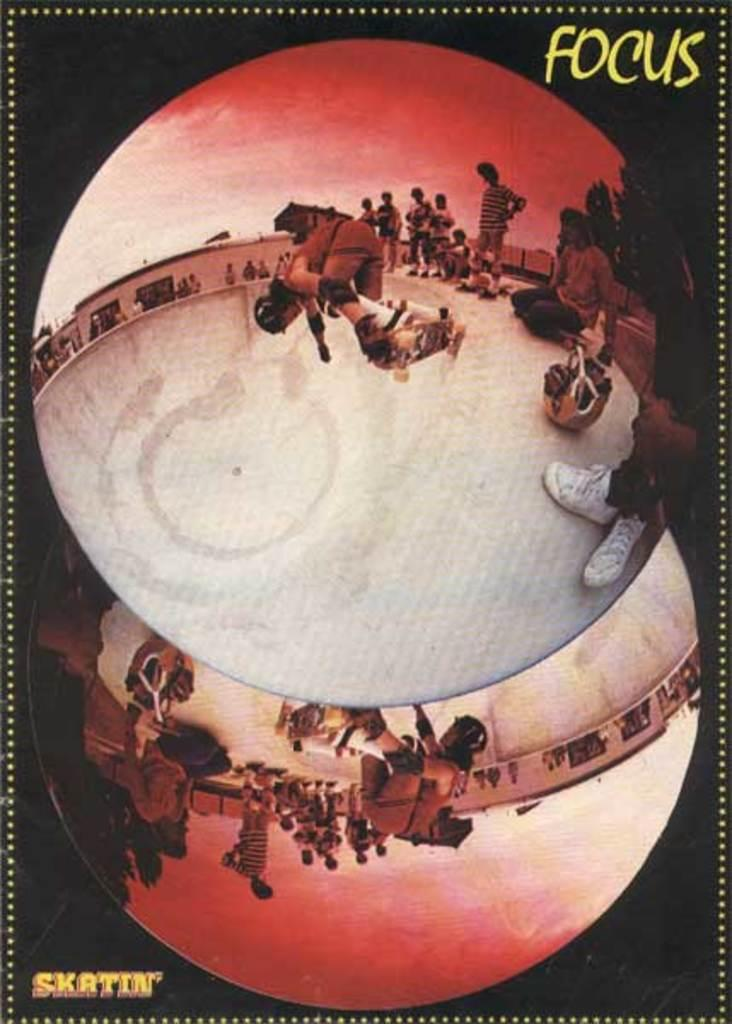<image>
Share a concise interpretation of the image provided. A poster featuring skateboarders by the brand called Focus. 